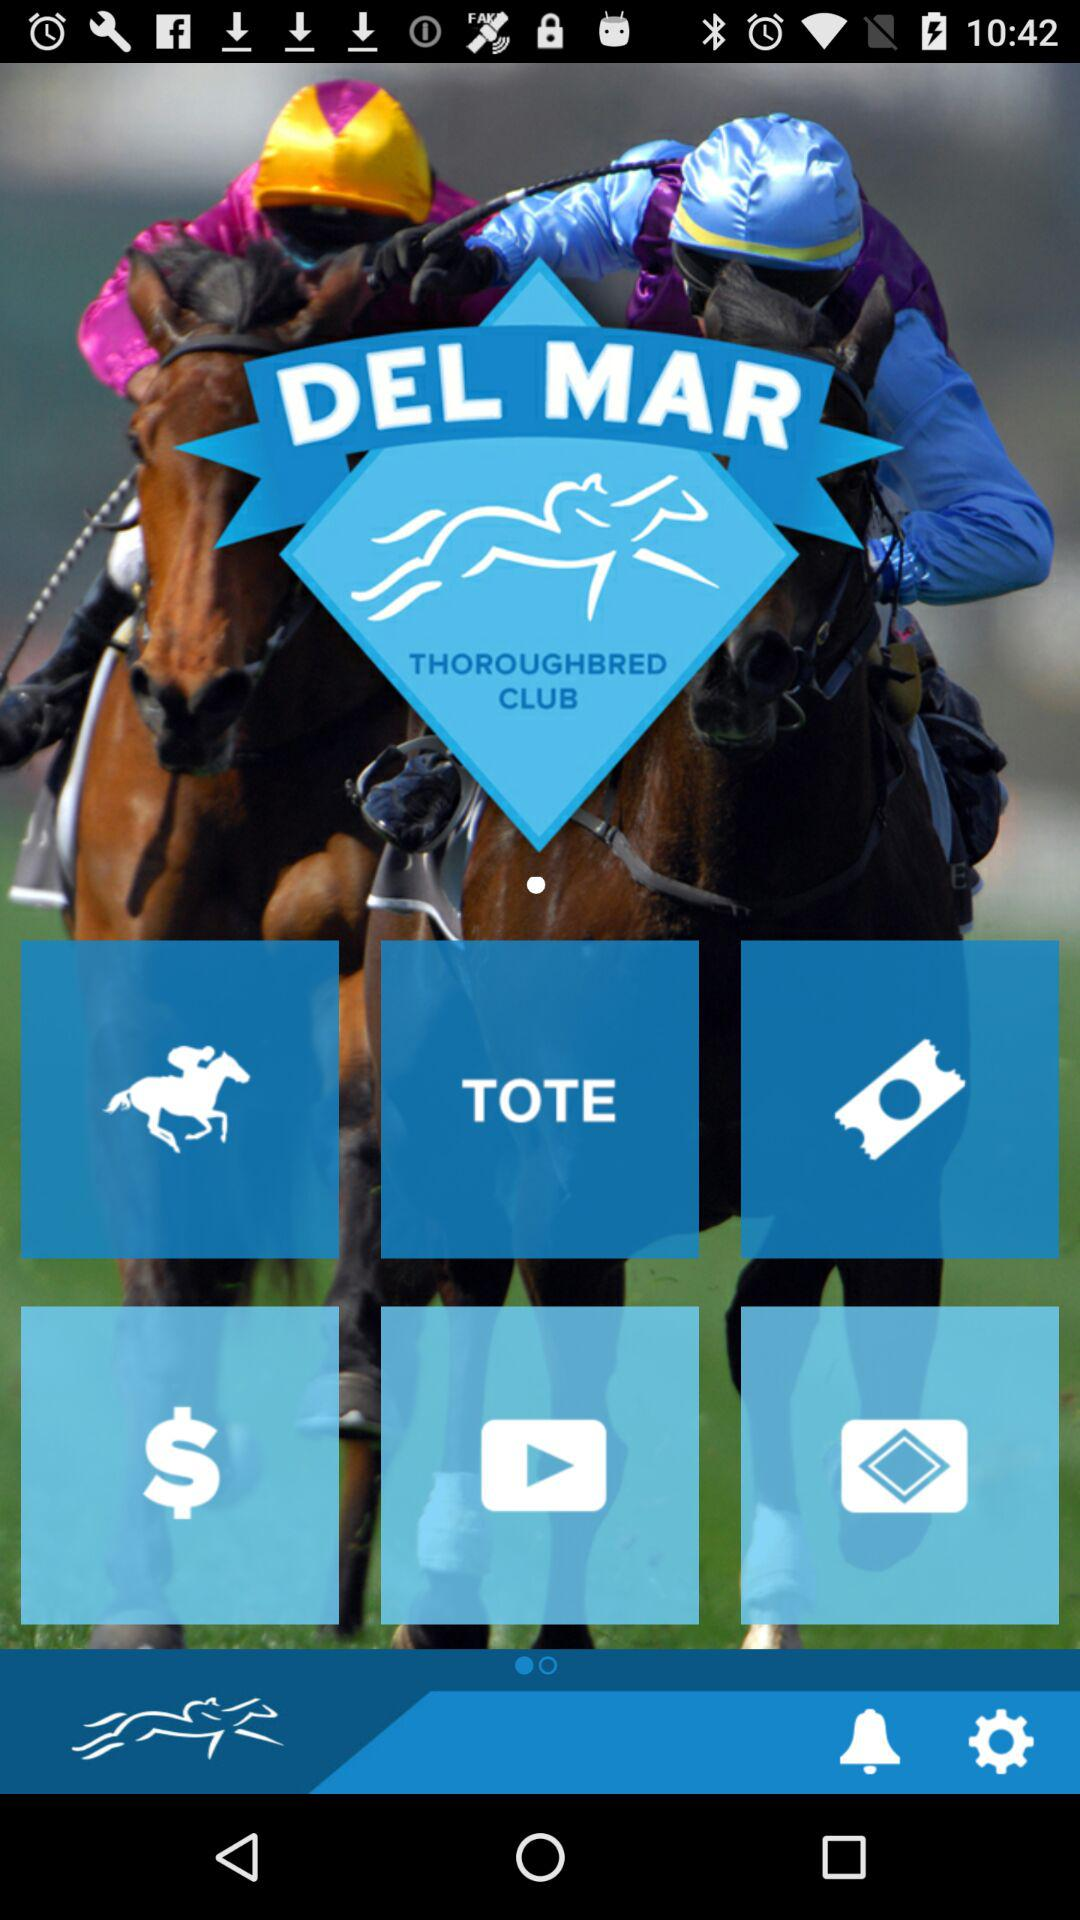What is the application name? The application name is "DEL MAR THOROUGHBRED CLUB". 